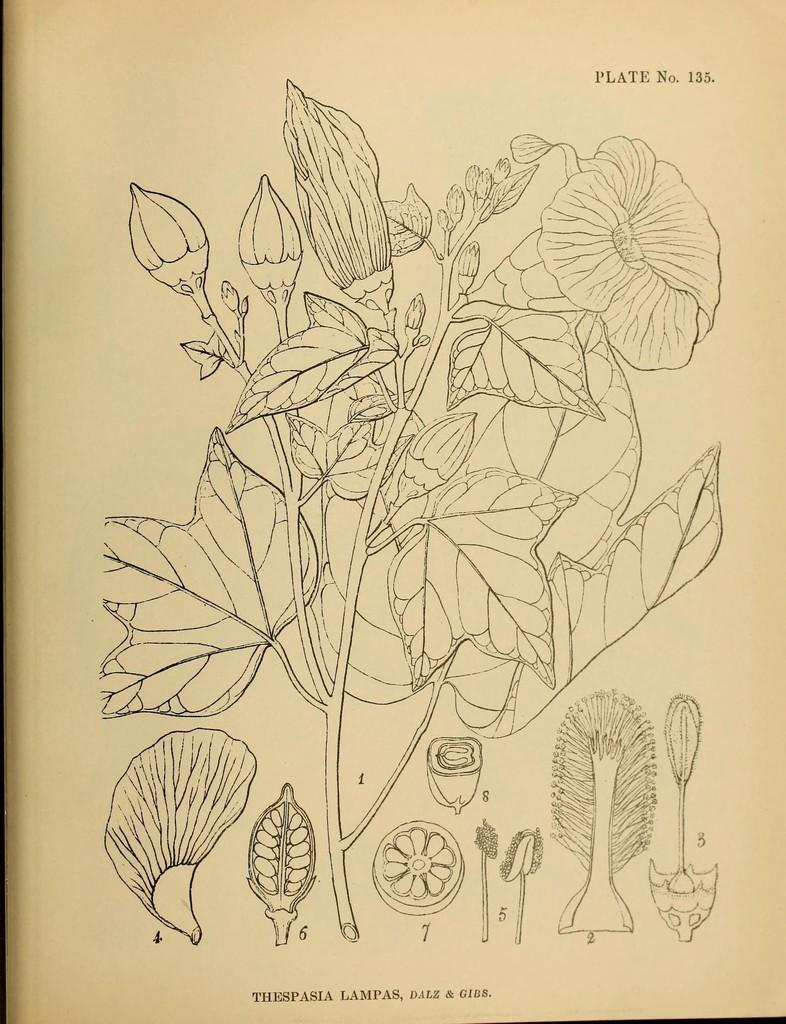What is depicted in the image? There is a diagram of a plant in the image. What can be seen in the diagram? There are flowers visible in the image. What color is the background of the image? The background of the image is in cream color. What time of day is it in the image? The time of day cannot be determined from the image, as it only contains a diagram of a plant and does not depict any specific time or setting. 